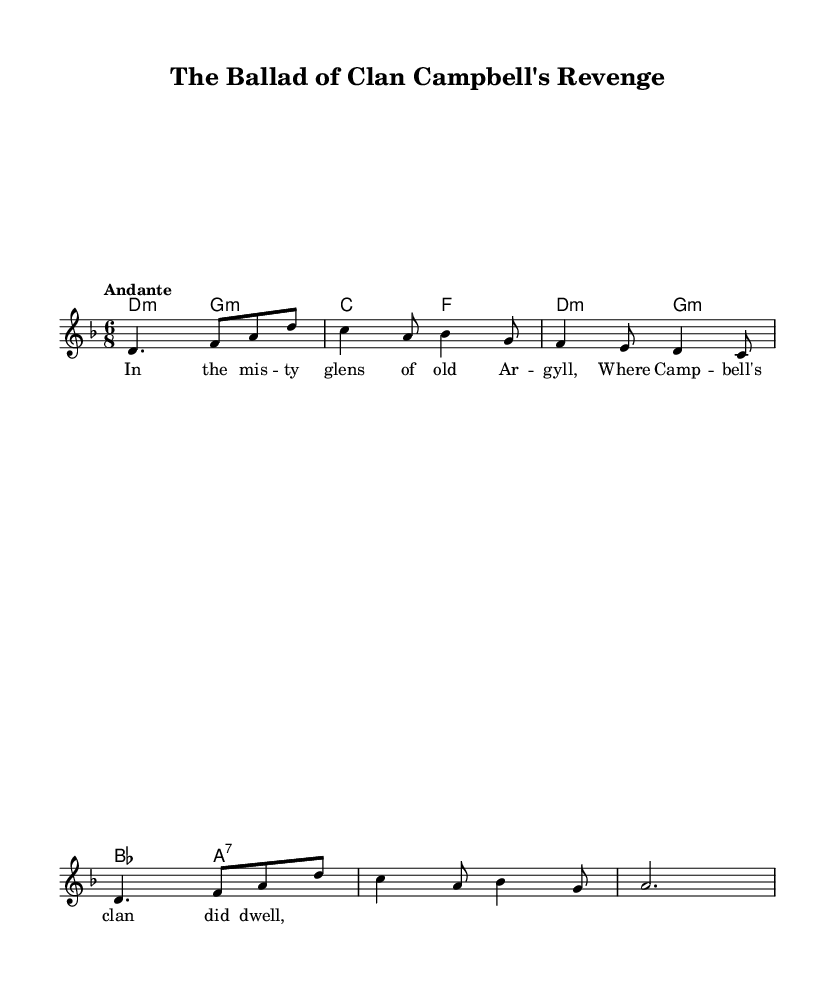What is the key signature of this music? The key signature is indicated at the beginning of the score, where it shows two flats. This indicates the key of D minor, which has one flat (C) and is the relative minor of F major, which has one flat.
Answer: D minor What is the time signature of this music? The time signature is located at the beginning next to the key signature. It shows a "6/8" which means there are six eighth notes per measure, typical of a compound duple meter.
Answer: 6/8 What is the tempo marking? The tempo marking is found above the staff and indicates the speed of the music; it says "Andante," which suggests a moderate pace, typically around 76-108 BPM.
Answer: Andante How many measures are in the melody? To determine the number of measures, I count the individual sections separated by vertical lines in the melody part. Each section corresponds to one measure. There are eight measures present in the melody.
Answer: Eight What are the first three notes of the melody? The first three notes of the melody can be read from the notation at the beginning of the score. They are "D," "F," and "A," which form the beginning of the melodic line.
Answer: D, F, A What is the text of the first verse? The text of the first verse is provided under the melody; it can be read as "In the misty glens of old Argyll, Where Campbell's clan did dwell." This is the introductory context for the ballad.
Answer: In the misty glens of old Argyll, Where Campbell's clan did dwell What type of ballad does this piece represent? This piece is labeled as a traditional Scottish folk ballad, which often reflects themes of clan conflicts and royal intrigue, typical of the historical context in which these stories were told.
Answer: Folk ballad 